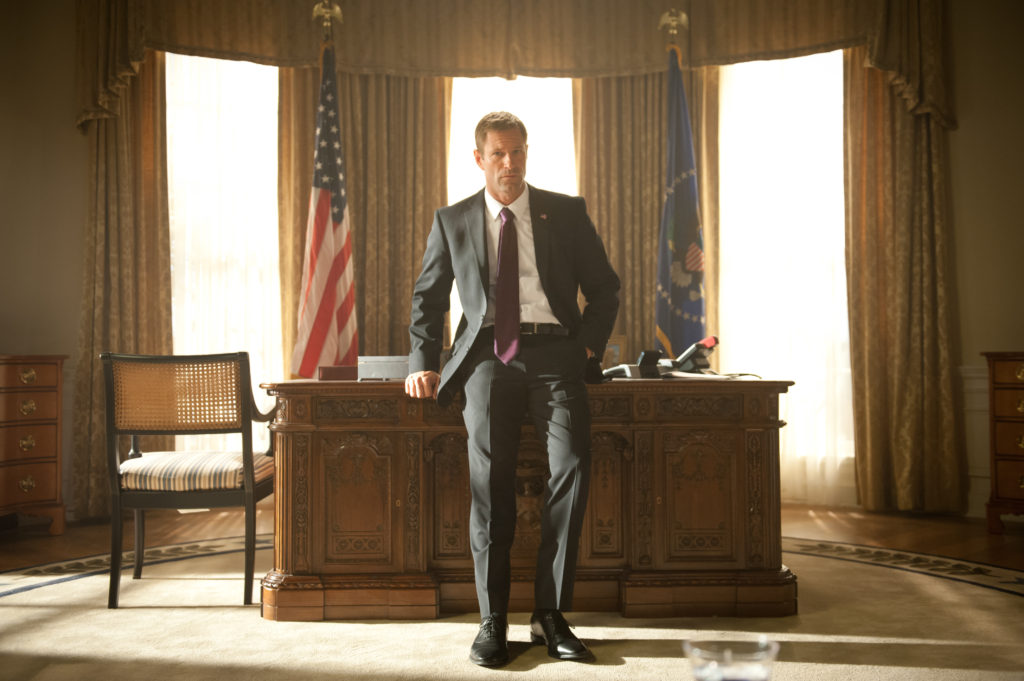Explain the visual content of the image in great detail. This image captures a scene from the movie 'Olympus Has Fallen,' showing Aaron Eckhart portraying President Benjamin Asher. He is seen standing in front of an intricately carved wooden desk within a room that strongly resembles the Oval Office of the White House. Behind him are two flags, one being the United States flag with its recognizable red, white, and blue colors. The second flag is a blue flag bearing a golden eagle, potentially the Presidential Standard. The room is warmly lit by natural light coming through the curtained windows behind him. Eckhart, dressed in a sharp black suit, white dress shirt, and a striking purple tie, conveys a serious demeanor as he leans slightly on the desk and gazes off to the side. The overall atmosphere exudes formality and significance, emphasizing the weight of his character's role as the President. 